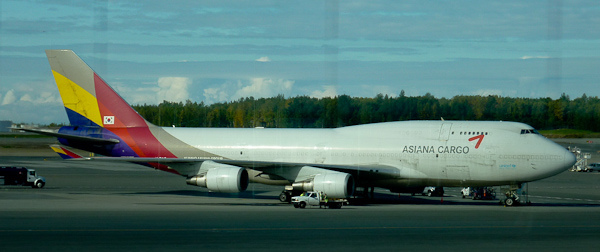Identify the text displayed in this image. ASIANA CARGO 